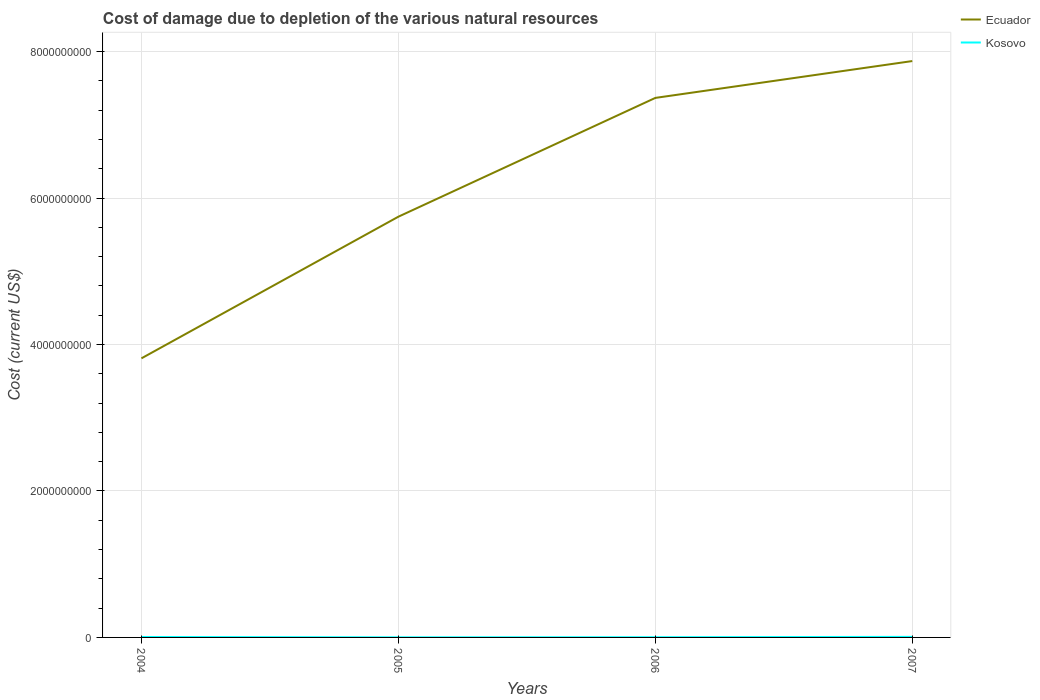Does the line corresponding to Ecuador intersect with the line corresponding to Kosovo?
Your answer should be very brief. No. Across all years, what is the maximum cost of damage caused due to the depletion of various natural resources in Kosovo?
Your answer should be very brief. 1.65e+06. In which year was the cost of damage caused due to the depletion of various natural resources in Ecuador maximum?
Your answer should be compact. 2004. What is the total cost of damage caused due to the depletion of various natural resources in Ecuador in the graph?
Provide a short and direct response. -4.06e+09. What is the difference between the highest and the second highest cost of damage caused due to the depletion of various natural resources in Ecuador?
Give a very brief answer. 4.06e+09. Are the values on the major ticks of Y-axis written in scientific E-notation?
Ensure brevity in your answer.  No. Does the graph contain any zero values?
Provide a succinct answer. No. How many legend labels are there?
Ensure brevity in your answer.  2. What is the title of the graph?
Ensure brevity in your answer.  Cost of damage due to depletion of the various natural resources. Does "Jordan" appear as one of the legend labels in the graph?
Your answer should be very brief. No. What is the label or title of the Y-axis?
Your answer should be very brief. Cost (current US$). What is the Cost (current US$) in Ecuador in 2004?
Provide a succinct answer. 3.81e+09. What is the Cost (current US$) of Kosovo in 2004?
Offer a terse response. 6.08e+06. What is the Cost (current US$) in Ecuador in 2005?
Give a very brief answer. 5.75e+09. What is the Cost (current US$) in Kosovo in 2005?
Provide a succinct answer. 1.65e+06. What is the Cost (current US$) of Ecuador in 2006?
Provide a short and direct response. 7.37e+09. What is the Cost (current US$) in Kosovo in 2006?
Provide a short and direct response. 3.07e+06. What is the Cost (current US$) of Ecuador in 2007?
Give a very brief answer. 7.87e+09. What is the Cost (current US$) of Kosovo in 2007?
Your answer should be very brief. 7.50e+06. Across all years, what is the maximum Cost (current US$) in Ecuador?
Your response must be concise. 7.87e+09. Across all years, what is the maximum Cost (current US$) of Kosovo?
Your response must be concise. 7.50e+06. Across all years, what is the minimum Cost (current US$) of Ecuador?
Make the answer very short. 3.81e+09. Across all years, what is the minimum Cost (current US$) of Kosovo?
Make the answer very short. 1.65e+06. What is the total Cost (current US$) of Ecuador in the graph?
Provide a short and direct response. 2.48e+1. What is the total Cost (current US$) in Kosovo in the graph?
Your answer should be very brief. 1.83e+07. What is the difference between the Cost (current US$) in Ecuador in 2004 and that in 2005?
Provide a succinct answer. -1.93e+09. What is the difference between the Cost (current US$) in Kosovo in 2004 and that in 2005?
Your answer should be very brief. 4.42e+06. What is the difference between the Cost (current US$) of Ecuador in 2004 and that in 2006?
Give a very brief answer. -3.56e+09. What is the difference between the Cost (current US$) in Kosovo in 2004 and that in 2006?
Your response must be concise. 3.00e+06. What is the difference between the Cost (current US$) in Ecuador in 2004 and that in 2007?
Give a very brief answer. -4.06e+09. What is the difference between the Cost (current US$) of Kosovo in 2004 and that in 2007?
Keep it short and to the point. -1.42e+06. What is the difference between the Cost (current US$) of Ecuador in 2005 and that in 2006?
Offer a very short reply. -1.62e+09. What is the difference between the Cost (current US$) of Kosovo in 2005 and that in 2006?
Keep it short and to the point. -1.42e+06. What is the difference between the Cost (current US$) in Ecuador in 2005 and that in 2007?
Your answer should be compact. -2.13e+09. What is the difference between the Cost (current US$) in Kosovo in 2005 and that in 2007?
Your answer should be very brief. -5.84e+06. What is the difference between the Cost (current US$) in Ecuador in 2006 and that in 2007?
Your answer should be very brief. -5.03e+08. What is the difference between the Cost (current US$) in Kosovo in 2006 and that in 2007?
Keep it short and to the point. -4.42e+06. What is the difference between the Cost (current US$) in Ecuador in 2004 and the Cost (current US$) in Kosovo in 2005?
Provide a short and direct response. 3.81e+09. What is the difference between the Cost (current US$) in Ecuador in 2004 and the Cost (current US$) in Kosovo in 2006?
Provide a short and direct response. 3.81e+09. What is the difference between the Cost (current US$) in Ecuador in 2004 and the Cost (current US$) in Kosovo in 2007?
Your answer should be very brief. 3.80e+09. What is the difference between the Cost (current US$) in Ecuador in 2005 and the Cost (current US$) in Kosovo in 2006?
Offer a very short reply. 5.74e+09. What is the difference between the Cost (current US$) in Ecuador in 2005 and the Cost (current US$) in Kosovo in 2007?
Your answer should be very brief. 5.74e+09. What is the difference between the Cost (current US$) of Ecuador in 2006 and the Cost (current US$) of Kosovo in 2007?
Offer a terse response. 7.36e+09. What is the average Cost (current US$) of Ecuador per year?
Make the answer very short. 6.20e+09. What is the average Cost (current US$) of Kosovo per year?
Offer a terse response. 4.58e+06. In the year 2004, what is the difference between the Cost (current US$) in Ecuador and Cost (current US$) in Kosovo?
Keep it short and to the point. 3.81e+09. In the year 2005, what is the difference between the Cost (current US$) of Ecuador and Cost (current US$) of Kosovo?
Your response must be concise. 5.74e+09. In the year 2006, what is the difference between the Cost (current US$) of Ecuador and Cost (current US$) of Kosovo?
Provide a succinct answer. 7.37e+09. In the year 2007, what is the difference between the Cost (current US$) of Ecuador and Cost (current US$) of Kosovo?
Keep it short and to the point. 7.86e+09. What is the ratio of the Cost (current US$) of Ecuador in 2004 to that in 2005?
Provide a succinct answer. 0.66. What is the ratio of the Cost (current US$) in Kosovo in 2004 to that in 2005?
Your answer should be compact. 3.67. What is the ratio of the Cost (current US$) of Ecuador in 2004 to that in 2006?
Ensure brevity in your answer.  0.52. What is the ratio of the Cost (current US$) in Kosovo in 2004 to that in 2006?
Your answer should be compact. 1.98. What is the ratio of the Cost (current US$) in Ecuador in 2004 to that in 2007?
Offer a terse response. 0.48. What is the ratio of the Cost (current US$) in Kosovo in 2004 to that in 2007?
Your answer should be very brief. 0.81. What is the ratio of the Cost (current US$) of Ecuador in 2005 to that in 2006?
Provide a succinct answer. 0.78. What is the ratio of the Cost (current US$) of Kosovo in 2005 to that in 2006?
Your answer should be compact. 0.54. What is the ratio of the Cost (current US$) of Ecuador in 2005 to that in 2007?
Offer a terse response. 0.73. What is the ratio of the Cost (current US$) in Kosovo in 2005 to that in 2007?
Ensure brevity in your answer.  0.22. What is the ratio of the Cost (current US$) of Ecuador in 2006 to that in 2007?
Give a very brief answer. 0.94. What is the ratio of the Cost (current US$) in Kosovo in 2006 to that in 2007?
Ensure brevity in your answer.  0.41. What is the difference between the highest and the second highest Cost (current US$) in Ecuador?
Keep it short and to the point. 5.03e+08. What is the difference between the highest and the second highest Cost (current US$) of Kosovo?
Offer a terse response. 1.42e+06. What is the difference between the highest and the lowest Cost (current US$) in Ecuador?
Keep it short and to the point. 4.06e+09. What is the difference between the highest and the lowest Cost (current US$) of Kosovo?
Provide a short and direct response. 5.84e+06. 